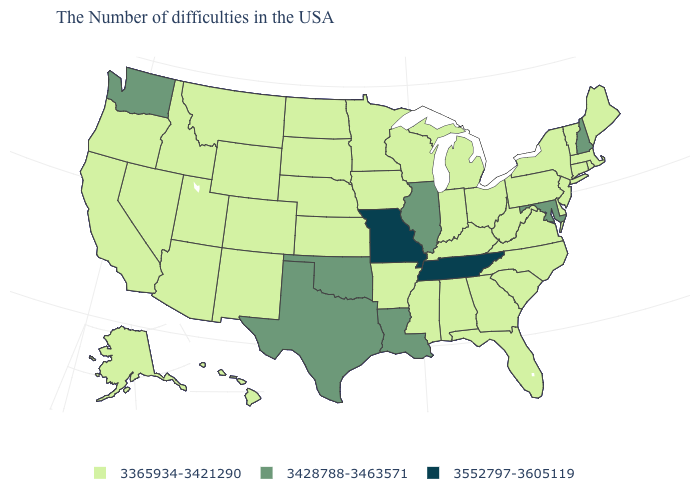Does Pennsylvania have the lowest value in the USA?
Be succinct. Yes. Which states have the highest value in the USA?
Be succinct. Tennessee, Missouri. What is the highest value in the USA?
Answer briefly. 3552797-3605119. Name the states that have a value in the range 3365934-3421290?
Keep it brief. Maine, Massachusetts, Rhode Island, Vermont, Connecticut, New York, New Jersey, Delaware, Pennsylvania, Virginia, North Carolina, South Carolina, West Virginia, Ohio, Florida, Georgia, Michigan, Kentucky, Indiana, Alabama, Wisconsin, Mississippi, Arkansas, Minnesota, Iowa, Kansas, Nebraska, South Dakota, North Dakota, Wyoming, Colorado, New Mexico, Utah, Montana, Arizona, Idaho, Nevada, California, Oregon, Alaska, Hawaii. Does the map have missing data?
Quick response, please. No. What is the value of Maine?
Keep it brief. 3365934-3421290. Name the states that have a value in the range 3552797-3605119?
Write a very short answer. Tennessee, Missouri. What is the highest value in the South ?
Concise answer only. 3552797-3605119. Name the states that have a value in the range 3428788-3463571?
Short answer required. New Hampshire, Maryland, Illinois, Louisiana, Oklahoma, Texas, Washington. What is the value of Pennsylvania?
Write a very short answer. 3365934-3421290. Name the states that have a value in the range 3365934-3421290?
Quick response, please. Maine, Massachusetts, Rhode Island, Vermont, Connecticut, New York, New Jersey, Delaware, Pennsylvania, Virginia, North Carolina, South Carolina, West Virginia, Ohio, Florida, Georgia, Michigan, Kentucky, Indiana, Alabama, Wisconsin, Mississippi, Arkansas, Minnesota, Iowa, Kansas, Nebraska, South Dakota, North Dakota, Wyoming, Colorado, New Mexico, Utah, Montana, Arizona, Idaho, Nevada, California, Oregon, Alaska, Hawaii. Does the map have missing data?
Give a very brief answer. No. Among the states that border Indiana , which have the highest value?
Quick response, please. Illinois. Does the map have missing data?
Answer briefly. No. What is the value of North Carolina?
Answer briefly. 3365934-3421290. 